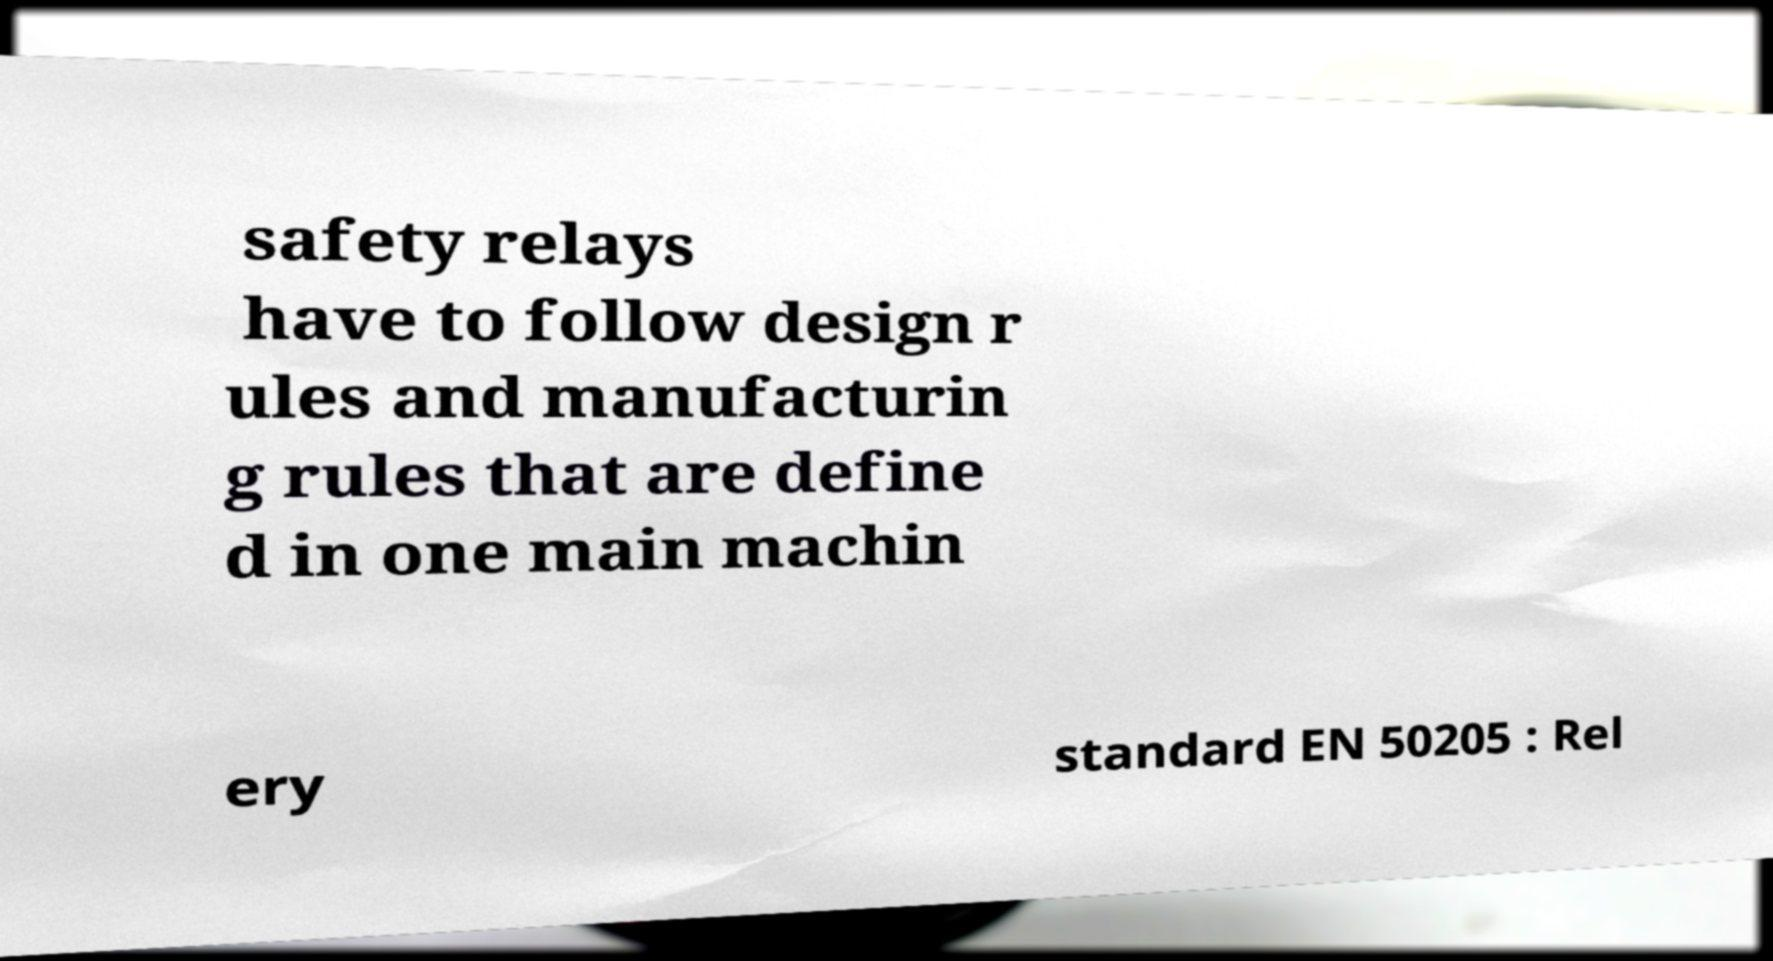Could you assist in decoding the text presented in this image and type it out clearly? safety relays have to follow design r ules and manufacturin g rules that are define d in one main machin ery standard EN 50205 : Rel 